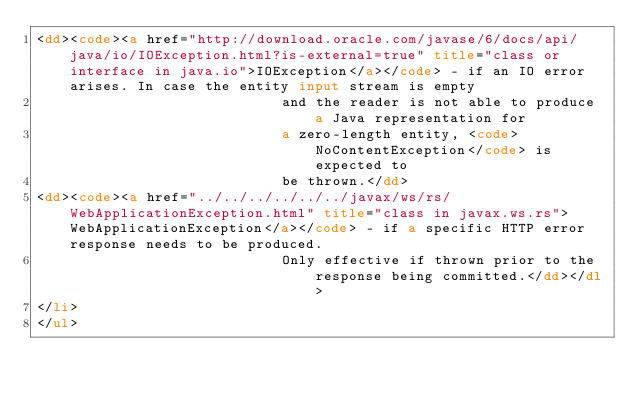<code> <loc_0><loc_0><loc_500><loc_500><_HTML_><dd><code><a href="http://download.oracle.com/javase/6/docs/api/java/io/IOException.html?is-external=true" title="class or interface in java.io">IOException</a></code> - if an IO error arises. In case the entity input stream is empty
                             and the reader is not able to produce a Java representation for
                             a zero-length entity, <code>NoContentException</code> is expected to
                             be thrown.</dd>
<dd><code><a href="../../../../../../javax/ws/rs/WebApplicationException.html" title="class in javax.ws.rs">WebApplicationException</a></code> - if a specific HTTP error response needs to be produced.
                             Only effective if thrown prior to the response being committed.</dd></dl>
</li>
</ul></code> 